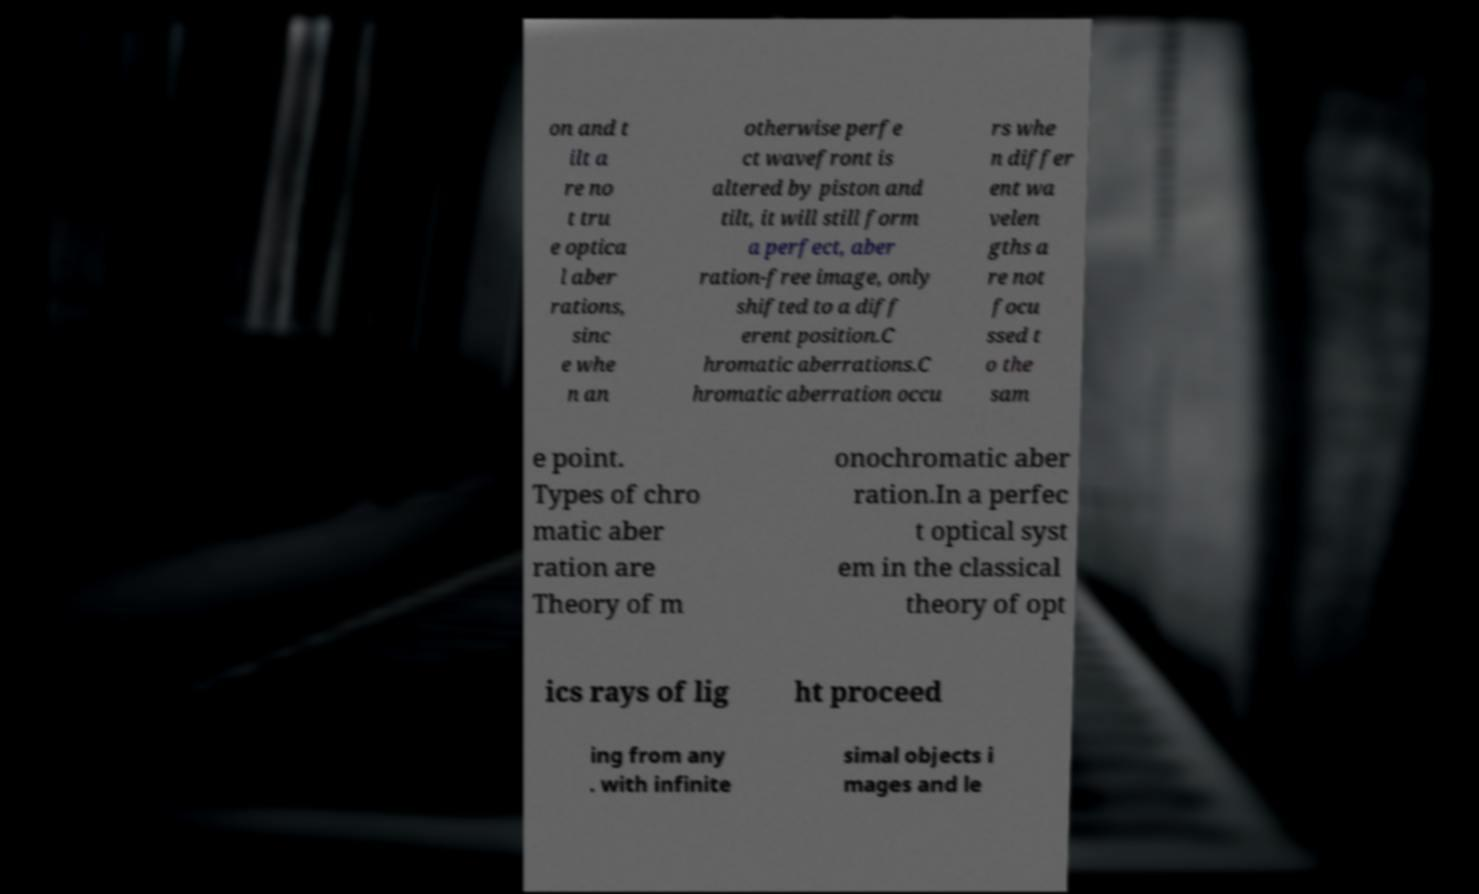Can you accurately transcribe the text from the provided image for me? on and t ilt a re no t tru e optica l aber rations, sinc e whe n an otherwise perfe ct wavefront is altered by piston and tilt, it will still form a perfect, aber ration-free image, only shifted to a diff erent position.C hromatic aberrations.C hromatic aberration occu rs whe n differ ent wa velen gths a re not focu ssed t o the sam e point. Types of chro matic aber ration are Theory of m onochromatic aber ration.In a perfec t optical syst em in the classical theory of opt ics rays of lig ht proceed ing from any . with infinite simal objects i mages and le 